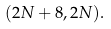<formula> <loc_0><loc_0><loc_500><loc_500>( 2 N + 8 , 2 N ) .</formula> 